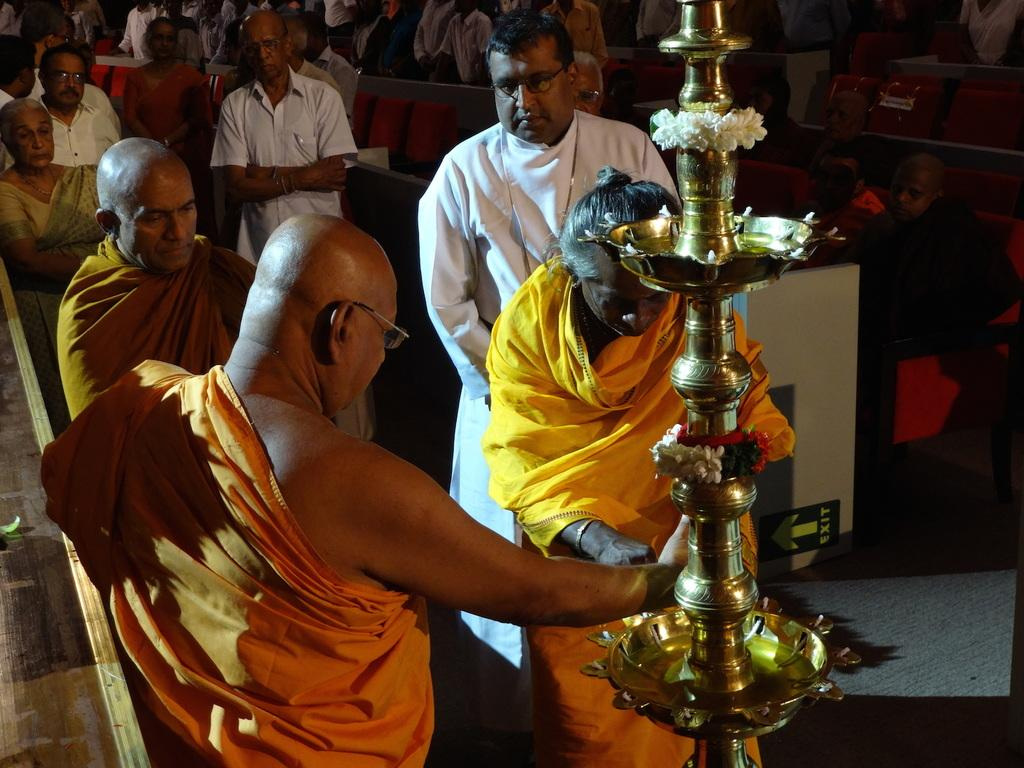How many people are in the image? There is a group of people in the image. What is the position of the people in the image? The people are standing on the ground. Can you describe the appearance of one person in the group? One person is wearing an orange dress and is wearing spectacles. What is the location of the person in the orange dress in relation to the lamp? The person in the orange dress is standing in front of a lamp. What decorative elements are present on the lamp? The lamp has flowers on it. What type of birds can be seen flying around the governor in the image? There is no governor or birds present in the image. What is the person in the orange dress holding in the image? The provided facts do not mention anything about the person in the orange dress holding an object. 